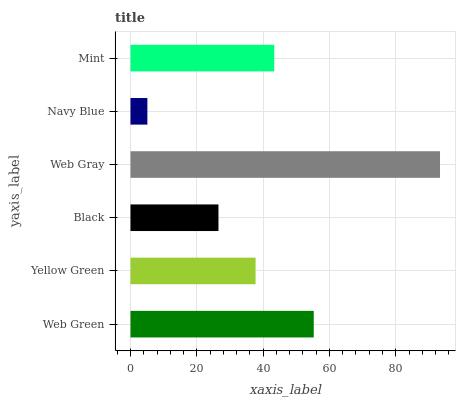Is Navy Blue the minimum?
Answer yes or no. Yes. Is Web Gray the maximum?
Answer yes or no. Yes. Is Yellow Green the minimum?
Answer yes or no. No. Is Yellow Green the maximum?
Answer yes or no. No. Is Web Green greater than Yellow Green?
Answer yes or no. Yes. Is Yellow Green less than Web Green?
Answer yes or no. Yes. Is Yellow Green greater than Web Green?
Answer yes or no. No. Is Web Green less than Yellow Green?
Answer yes or no. No. Is Mint the high median?
Answer yes or no. Yes. Is Yellow Green the low median?
Answer yes or no. Yes. Is Navy Blue the high median?
Answer yes or no. No. Is Web Gray the low median?
Answer yes or no. No. 